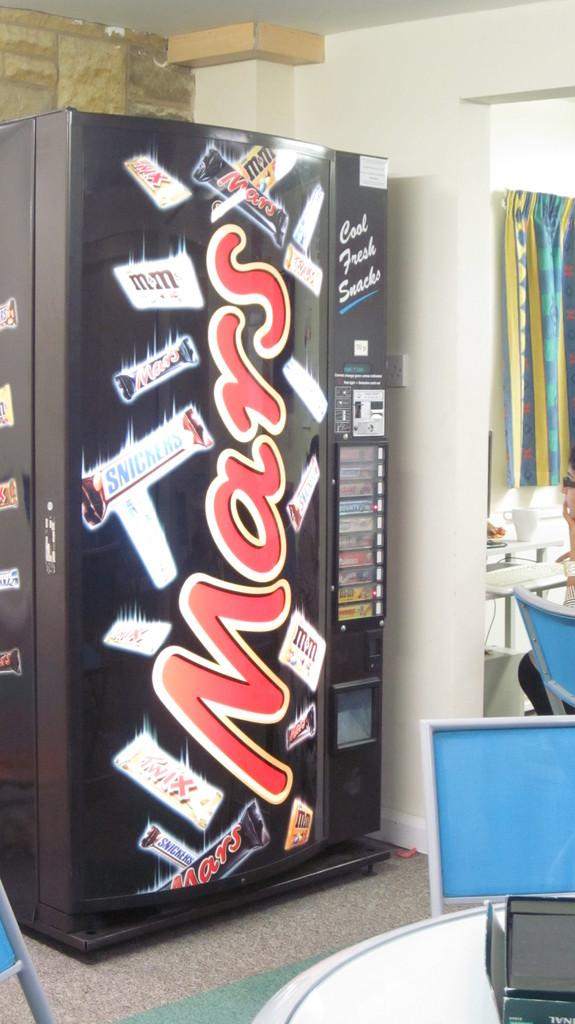Provide a one-sentence caption for the provided image. A black vending machine with the word Mars written in red letters. 